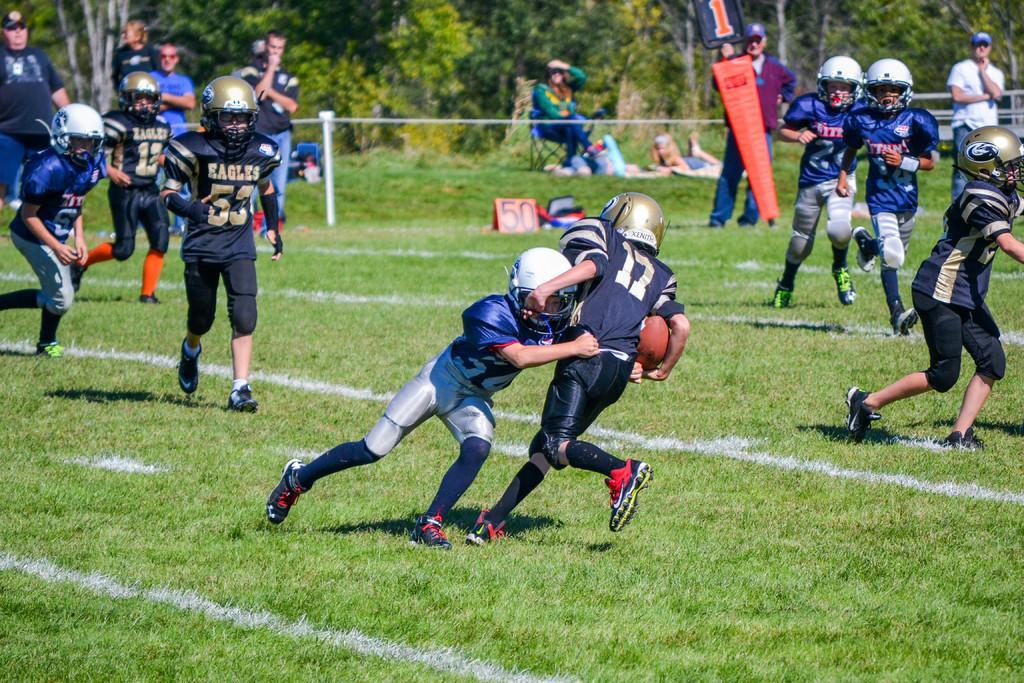Describe this image in one or two sentences. In this image there are group of people playing a game with a ball , and in the background there is grass, iron rods, a person sitting on the chair, plants. 